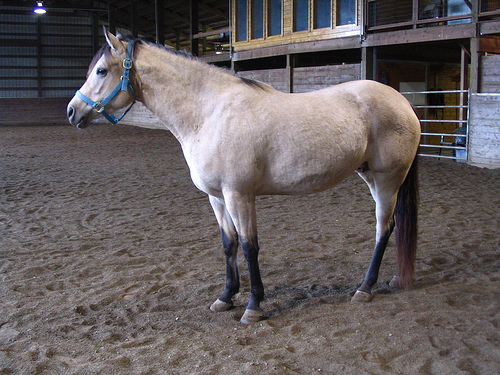<image>
Can you confirm if the horse is in front of the building? Yes. The horse is positioned in front of the building, appearing closer to the camera viewpoint. 